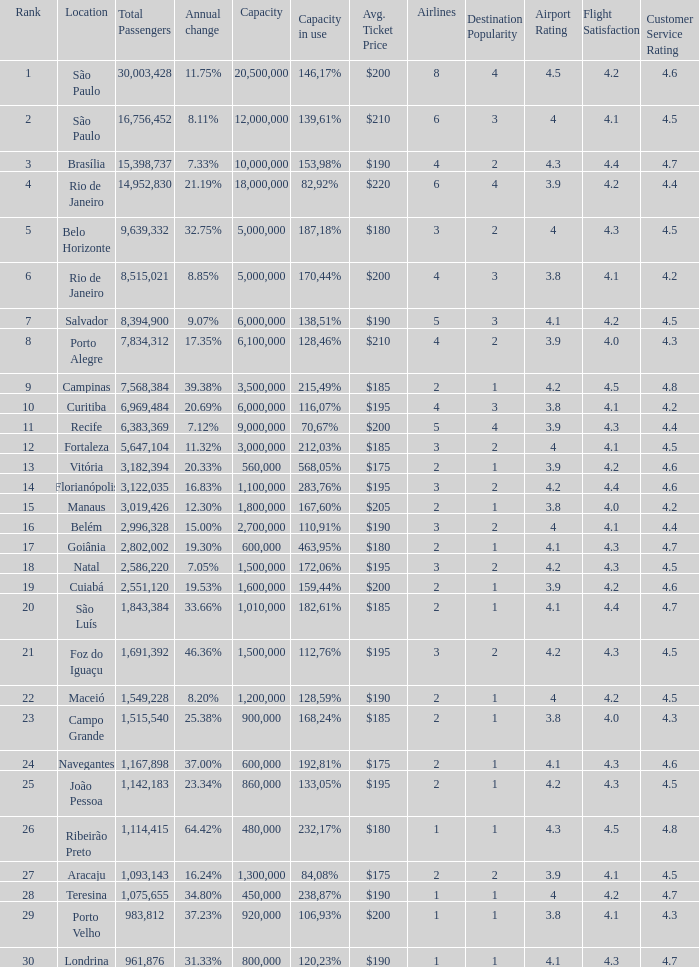Which location has a capacity that has a rank of 23? 168,24%. 